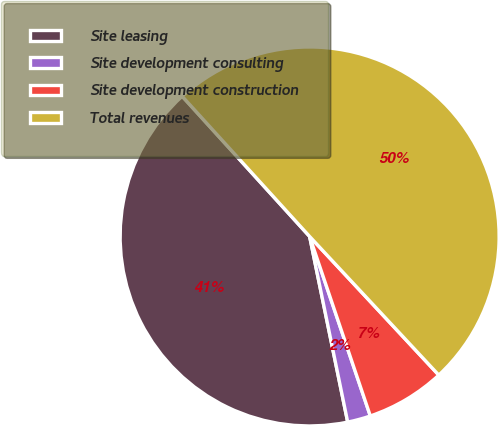Convert chart. <chart><loc_0><loc_0><loc_500><loc_500><pie_chart><fcel>Site leasing<fcel>Site development consulting<fcel>Site development construction<fcel>Total revenues<nl><fcel>41.48%<fcel>1.97%<fcel>6.75%<fcel>49.81%<nl></chart> 